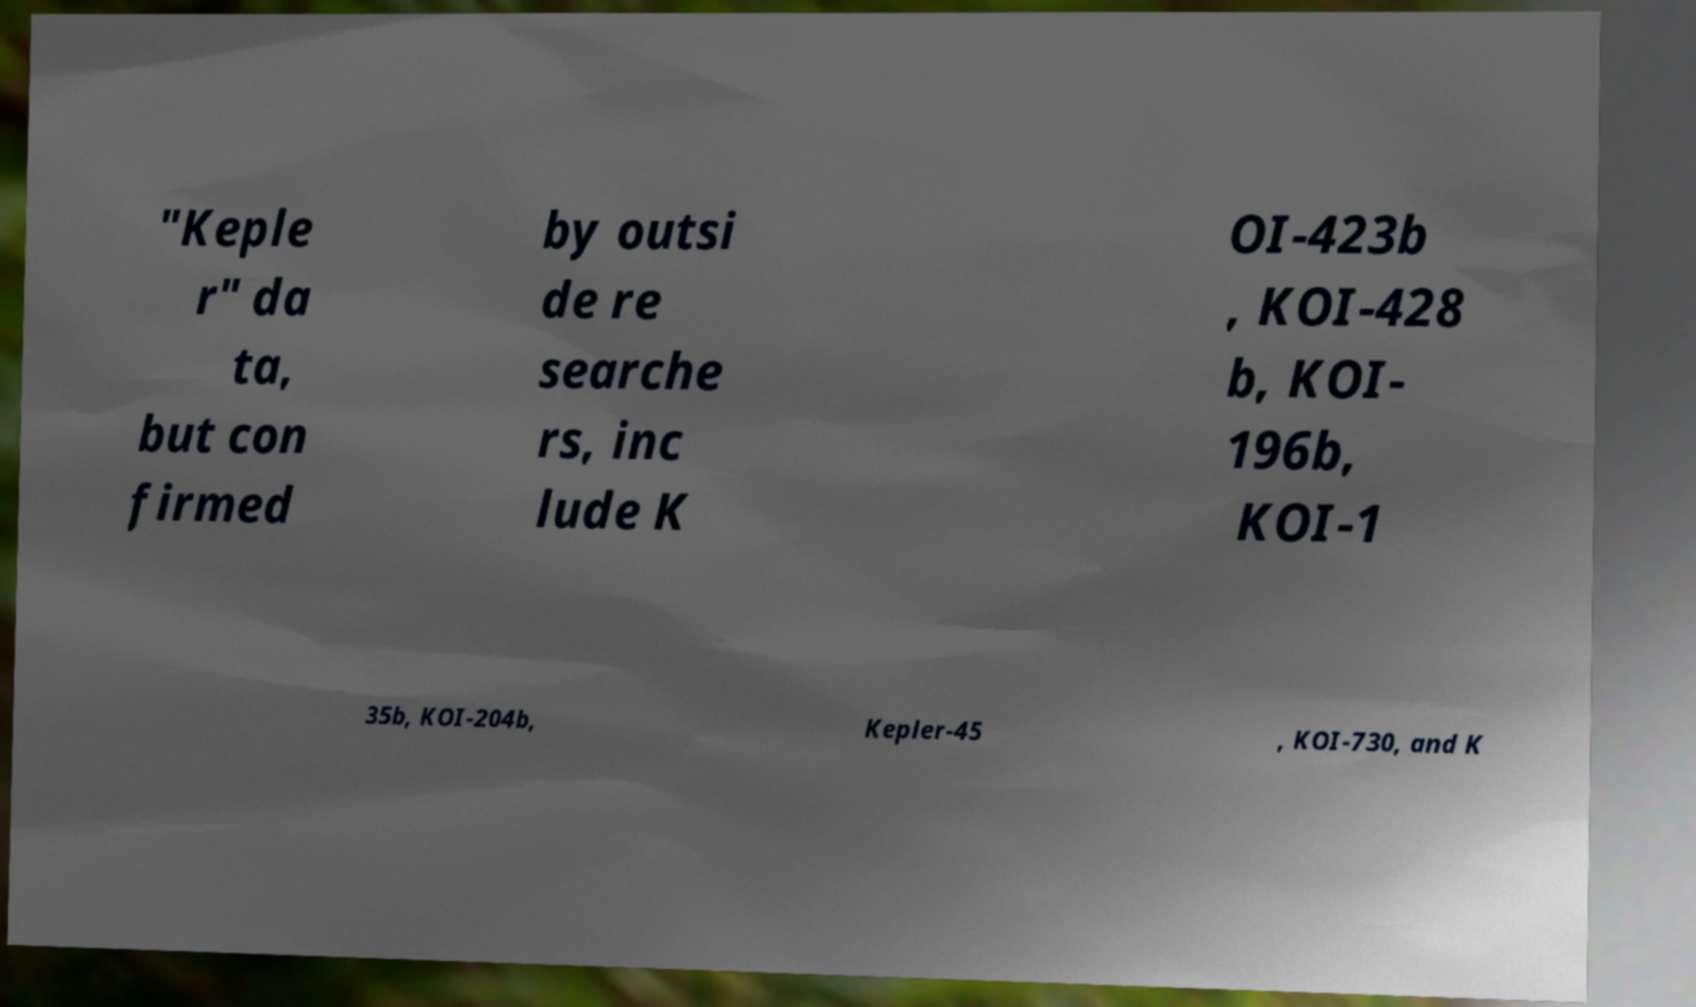I need the written content from this picture converted into text. Can you do that? "Keple r" da ta, but con firmed by outsi de re searche rs, inc lude K OI-423b , KOI-428 b, KOI- 196b, KOI-1 35b, KOI-204b, Kepler-45 , KOI-730, and K 